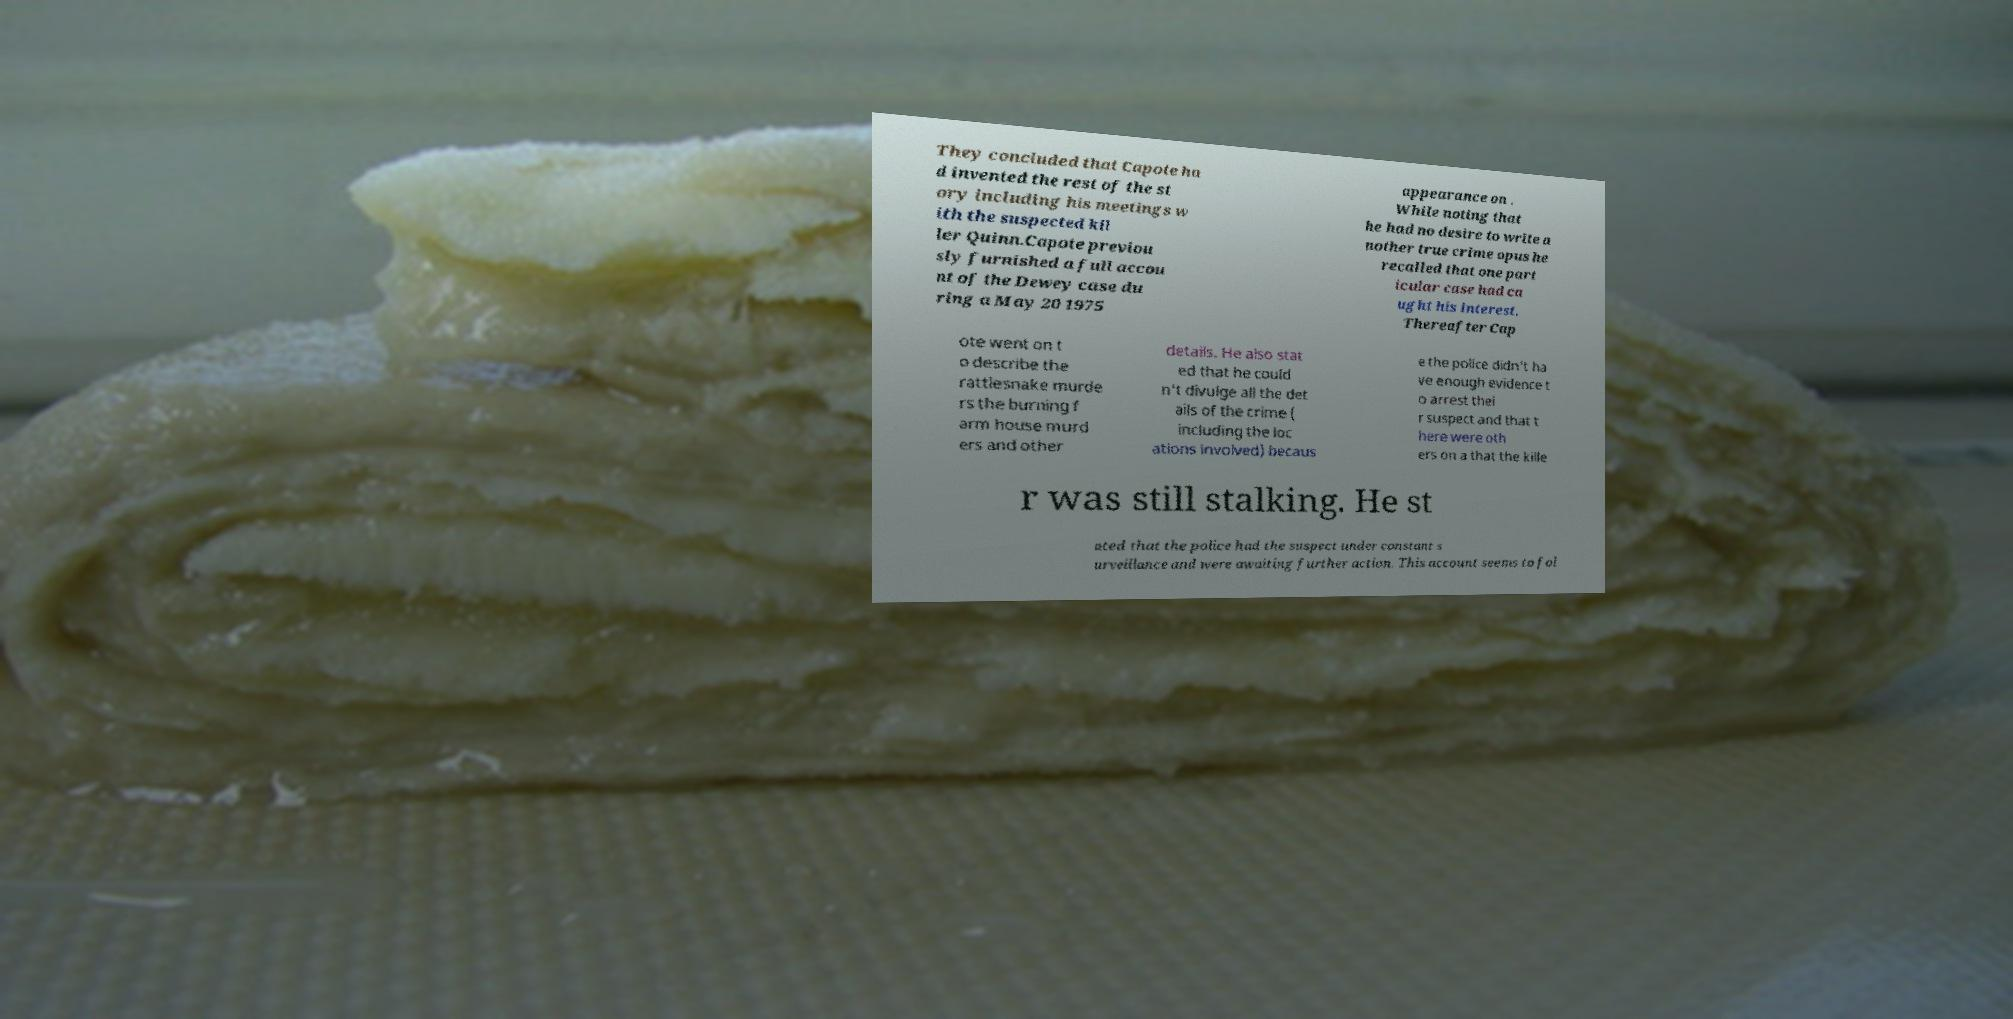Please identify and transcribe the text found in this image. They concluded that Capote ha d invented the rest of the st ory including his meetings w ith the suspected kil ler Quinn.Capote previou sly furnished a full accou nt of the Dewey case du ring a May 20 1975 appearance on . While noting that he had no desire to write a nother true crime opus he recalled that one part icular case had ca ught his interest. Thereafter Cap ote went on t o describe the rattlesnake murde rs the burning f arm house murd ers and other details. He also stat ed that he could n't divulge all the det ails of the crime ( including the loc ations involved) becaus e the police didn't ha ve enough evidence t o arrest thei r suspect and that t here were oth ers on a that the kille r was still stalking. He st ated that the police had the suspect under constant s urveillance and were awaiting further action. This account seems to fol 